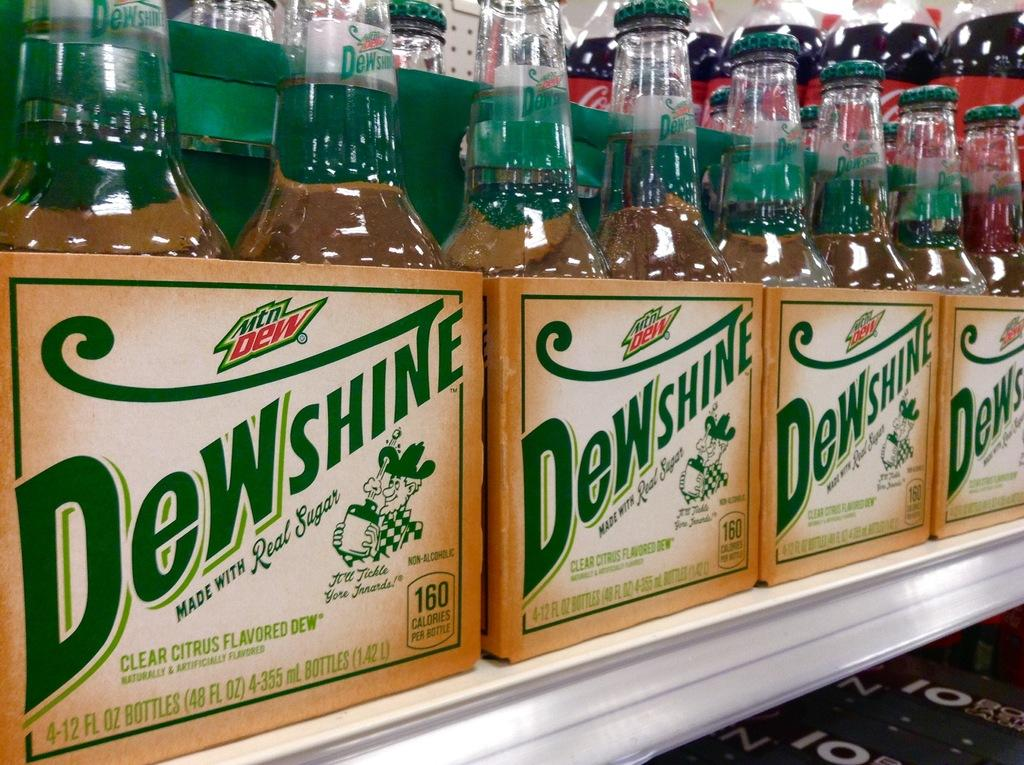<image>
Offer a succinct explanation of the picture presented. Bottles on a shelf with the brand name called Dew Shine 